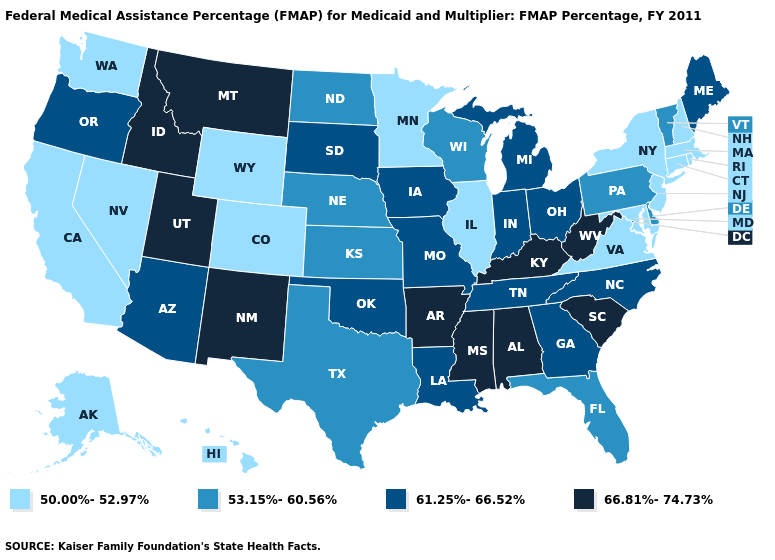Which states hav the highest value in the South?
Answer briefly. Alabama, Arkansas, Kentucky, Mississippi, South Carolina, West Virginia. What is the value of Michigan?
Be succinct. 61.25%-66.52%. Does Alabama have the lowest value in the USA?
Give a very brief answer. No. Which states have the lowest value in the West?
Answer briefly. Alaska, California, Colorado, Hawaii, Nevada, Washington, Wyoming. Does Arkansas have the same value as Mississippi?
Be succinct. Yes. What is the lowest value in states that border Montana?
Concise answer only. 50.00%-52.97%. Among the states that border California , which have the highest value?
Answer briefly. Arizona, Oregon. What is the value of Washington?
Concise answer only. 50.00%-52.97%. Name the states that have a value in the range 50.00%-52.97%?
Quick response, please. Alaska, California, Colorado, Connecticut, Hawaii, Illinois, Maryland, Massachusetts, Minnesota, Nevada, New Hampshire, New Jersey, New York, Rhode Island, Virginia, Washington, Wyoming. What is the highest value in states that border Massachusetts?
Short answer required. 53.15%-60.56%. Which states hav the highest value in the South?
Quick response, please. Alabama, Arkansas, Kentucky, Mississippi, South Carolina, West Virginia. What is the value of Maryland?
Answer briefly. 50.00%-52.97%. Among the states that border Kentucky , does Illinois have the lowest value?
Answer briefly. Yes. Does West Virginia have the lowest value in the USA?
Quick response, please. No. 